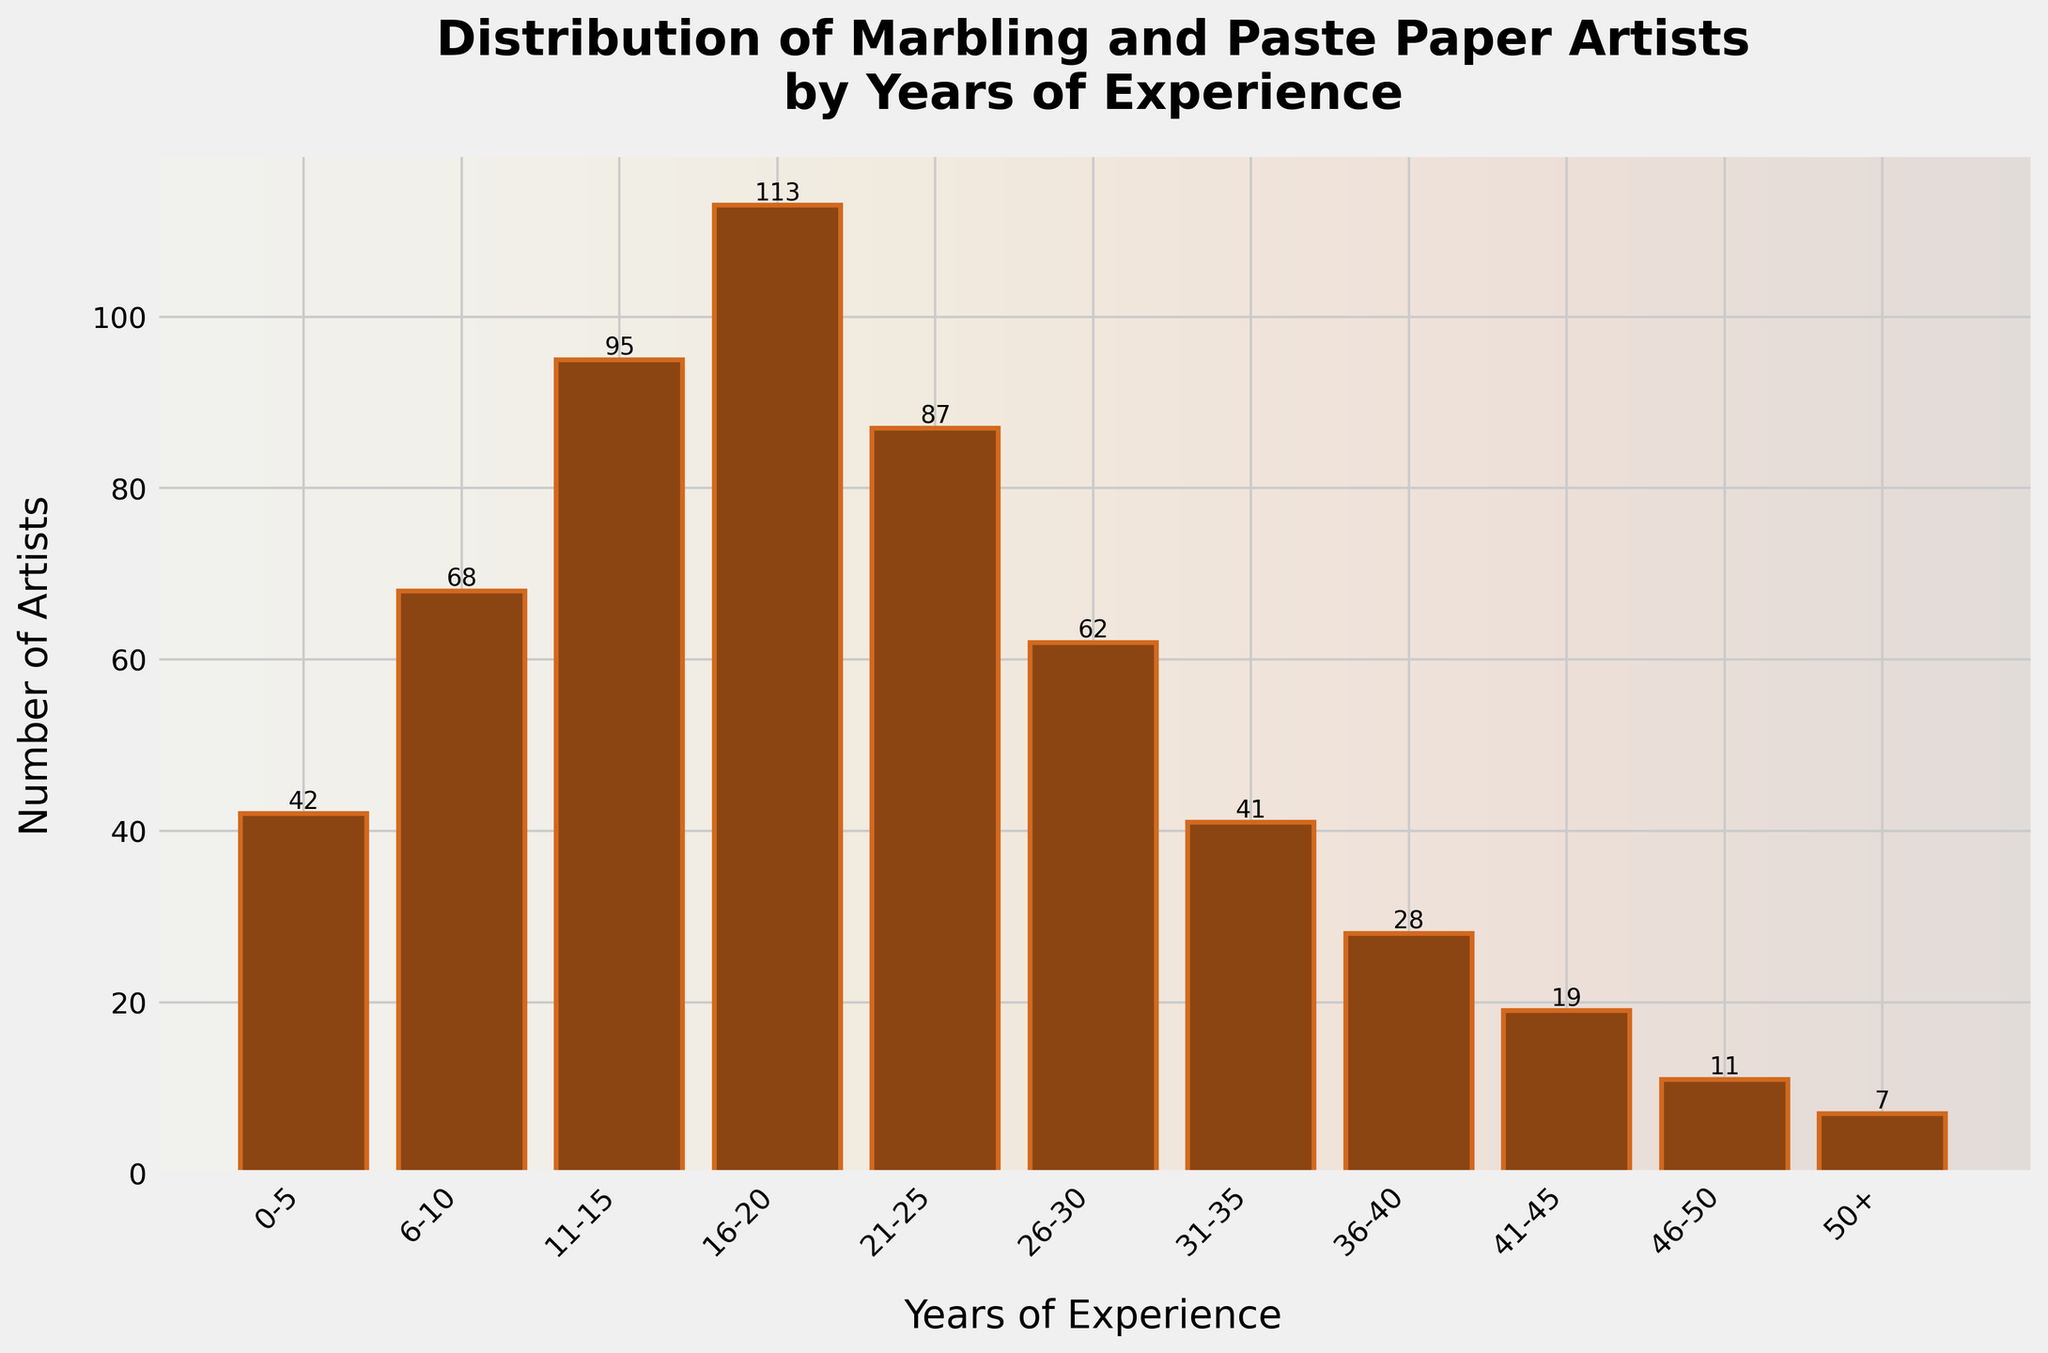What is the total number of artists with 21-25 and 26-30 years of experience? Sum the number of artists in the 21-25 range (87) and the 26-30 range (62). So, 87 + 62 = 149.
Answer: 149 Which group has the highest number of artists? Identify the bar with the greatest height. The 16-20 years of experience group has the highest number (113).
Answer: 16-20 years How many artists have more than 30 years of experience? Sum the number of artists in the 31-35 (41), 36-40 (28), 41-45 (19), 46-50 (11), and 50+ (7) categories. So, 41 + 28 + 19 + 11 + 7 = 106.
Answer: 106 What is the difference in the number of artists between the 11-15 and 41-45 years of experience groups? Subtract the number of artists in the 41-45 range (19) from the number in the 11-15 range (95). So, 95 - 19 = 76.
Answer: 76 Which two adjacent experience groups have the smallest difference in the number of artists? Compare the differences between adjacent groups. The smallest difference is between the 0-5 years (42) and 6-10 years (68) groups. The difference is 68 - 42 = 26.
Answer: 0-5 and 6-10 What is the average number of artists across all experience groups? Sum all the number of artists and divide by the number of groups. So, (42 + 68 + 95 + 113 + 87 + 62 + 41 + 28 + 19 + 11 + 7) / 11 = 52.18 (rounded to 2 decimal places).
Answer: 52.18 How does the number of artists in the 21-25 years group compare to the 0-5 years group? Identify the numbers for each group: 21-25 years has 87 artists, and 0-5 years has 42 artists. Compare 87 and 42. The 21-25 years group has more artists.
Answer: 21-25 is greater Which experience group has the fewest artists? Identify the bar with the smallest height. The 50+ years of experience group has the fewest artists (7).
Answer: 50+ years What is the combined number of artists in the two largest groups? The largest groups are 16-20 years (113) and 11-15 years (95). Sum these numbers: 113 + 95 = 208.
Answer: 208 